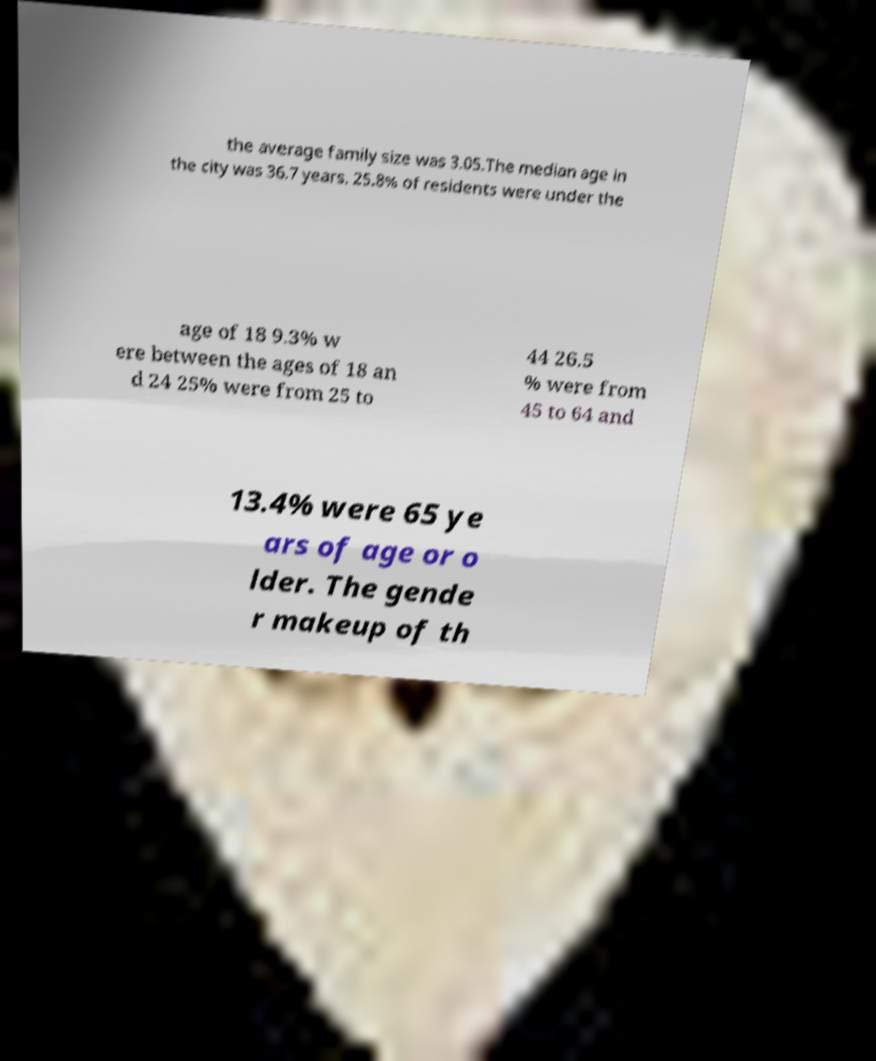What messages or text are displayed in this image? I need them in a readable, typed format. the average family size was 3.05.The median age in the city was 36.7 years. 25.8% of residents were under the age of 18 9.3% w ere between the ages of 18 an d 24 25% were from 25 to 44 26.5 % were from 45 to 64 and 13.4% were 65 ye ars of age or o lder. The gende r makeup of th 